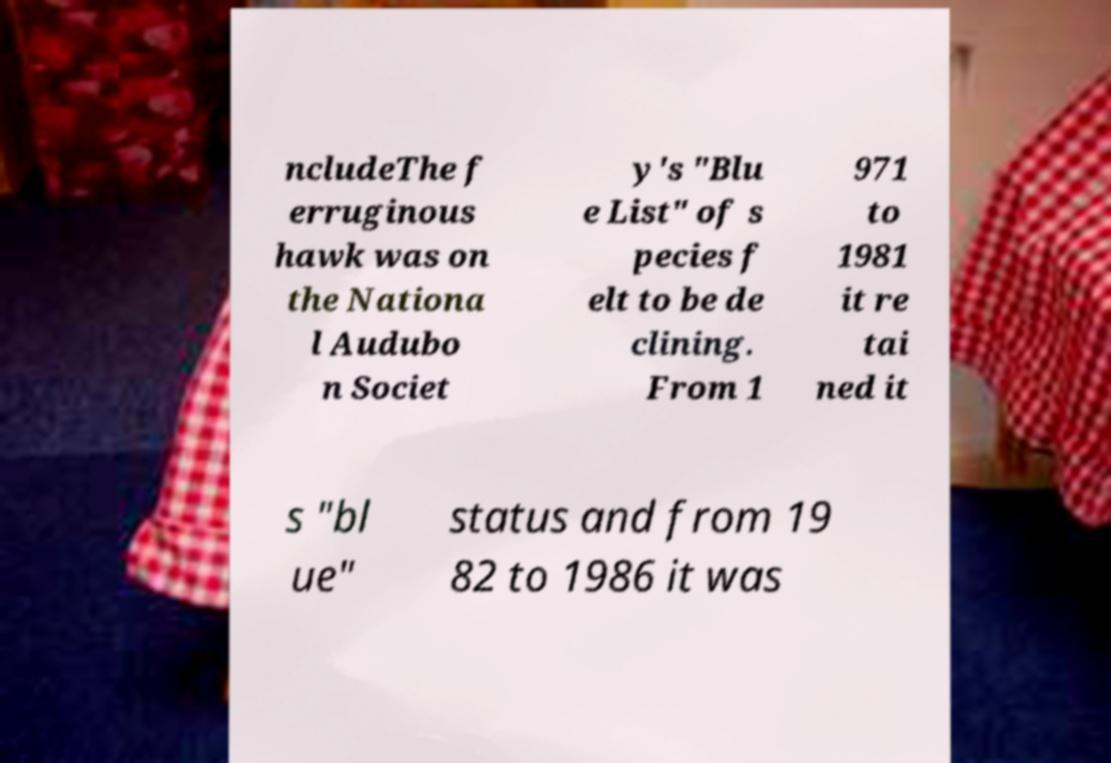Could you assist in decoding the text presented in this image and type it out clearly? ncludeThe f erruginous hawk was on the Nationa l Audubo n Societ y's "Blu e List" of s pecies f elt to be de clining. From 1 971 to 1981 it re tai ned it s "bl ue" status and from 19 82 to 1986 it was 